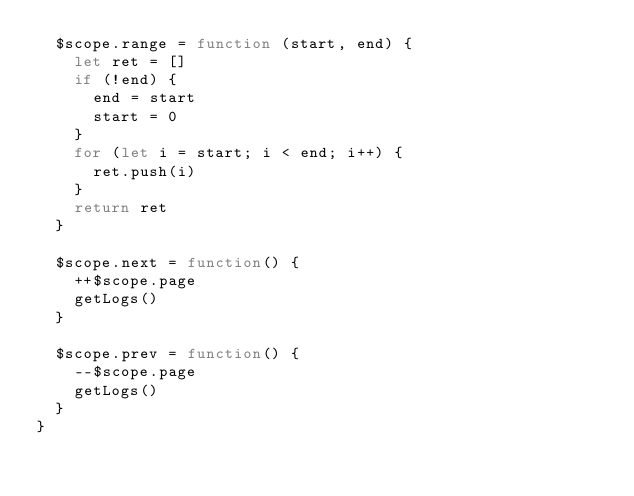Convert code to text. <code><loc_0><loc_0><loc_500><loc_500><_JavaScript_>  $scope.range = function (start, end) {
    let ret = []
    if (!end) {
      end = start
      start = 0
    }
    for (let i = start; i < end; i++) {
      ret.push(i)
    }
    return ret
  }

  $scope.next = function() {
    ++$scope.page
    getLogs()
  }

  $scope.prev = function() {
    --$scope.page
    getLogs()
  }
}
</code> 